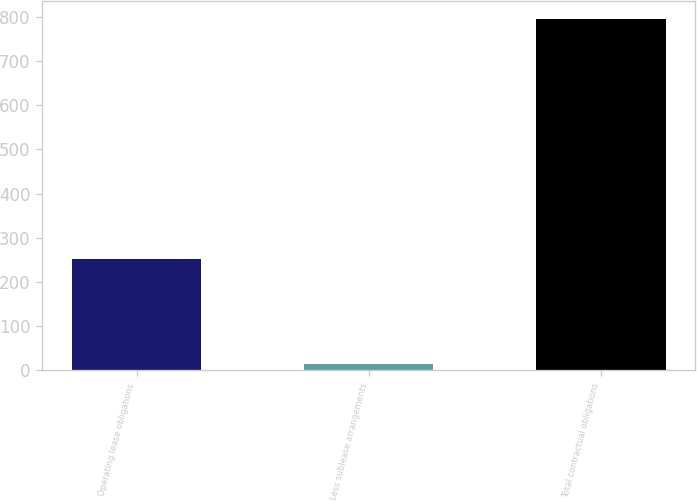Convert chart to OTSL. <chart><loc_0><loc_0><loc_500><loc_500><bar_chart><fcel>Operating lease obligations<fcel>Less sublease arrangements<fcel>Total contractual obligations<nl><fcel>251.4<fcel>13.8<fcel>796<nl></chart> 